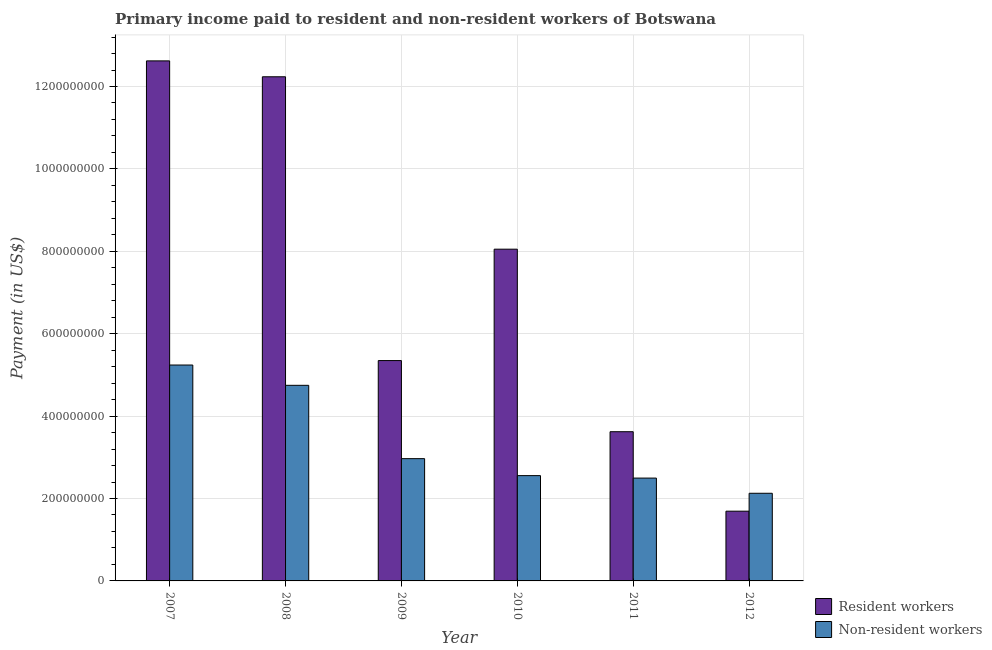How many different coloured bars are there?
Your answer should be very brief. 2. How many bars are there on the 5th tick from the right?
Keep it short and to the point. 2. What is the label of the 5th group of bars from the left?
Your answer should be very brief. 2011. What is the payment made to non-resident workers in 2012?
Your answer should be very brief. 2.13e+08. Across all years, what is the maximum payment made to resident workers?
Provide a succinct answer. 1.26e+09. Across all years, what is the minimum payment made to non-resident workers?
Ensure brevity in your answer.  2.13e+08. In which year was the payment made to non-resident workers minimum?
Make the answer very short. 2012. What is the total payment made to non-resident workers in the graph?
Make the answer very short. 2.01e+09. What is the difference between the payment made to non-resident workers in 2010 and that in 2011?
Your answer should be compact. 5.99e+06. What is the difference between the payment made to non-resident workers in 2012 and the payment made to resident workers in 2011?
Your answer should be compact. -3.69e+07. What is the average payment made to non-resident workers per year?
Make the answer very short. 3.36e+08. In the year 2012, what is the difference between the payment made to resident workers and payment made to non-resident workers?
Provide a short and direct response. 0. What is the ratio of the payment made to non-resident workers in 2008 to that in 2012?
Provide a short and direct response. 2.23. What is the difference between the highest and the second highest payment made to resident workers?
Provide a succinct answer. 3.86e+07. What is the difference between the highest and the lowest payment made to resident workers?
Provide a short and direct response. 1.09e+09. In how many years, is the payment made to non-resident workers greater than the average payment made to non-resident workers taken over all years?
Your response must be concise. 2. Is the sum of the payment made to resident workers in 2009 and 2012 greater than the maximum payment made to non-resident workers across all years?
Offer a very short reply. No. What does the 2nd bar from the left in 2011 represents?
Provide a succinct answer. Non-resident workers. What does the 1st bar from the right in 2012 represents?
Provide a succinct answer. Non-resident workers. How many bars are there?
Give a very brief answer. 12. Are all the bars in the graph horizontal?
Provide a short and direct response. No. How many years are there in the graph?
Your response must be concise. 6. What is the difference between two consecutive major ticks on the Y-axis?
Keep it short and to the point. 2.00e+08. Does the graph contain grids?
Offer a terse response. Yes. How many legend labels are there?
Provide a succinct answer. 2. How are the legend labels stacked?
Your answer should be compact. Vertical. What is the title of the graph?
Give a very brief answer. Primary income paid to resident and non-resident workers of Botswana. What is the label or title of the Y-axis?
Make the answer very short. Payment (in US$). What is the Payment (in US$) of Resident workers in 2007?
Your answer should be compact. 1.26e+09. What is the Payment (in US$) in Non-resident workers in 2007?
Your answer should be very brief. 5.24e+08. What is the Payment (in US$) of Resident workers in 2008?
Your response must be concise. 1.22e+09. What is the Payment (in US$) of Non-resident workers in 2008?
Ensure brevity in your answer.  4.75e+08. What is the Payment (in US$) in Resident workers in 2009?
Offer a terse response. 5.35e+08. What is the Payment (in US$) in Non-resident workers in 2009?
Provide a short and direct response. 2.97e+08. What is the Payment (in US$) in Resident workers in 2010?
Provide a succinct answer. 8.05e+08. What is the Payment (in US$) of Non-resident workers in 2010?
Your answer should be very brief. 2.56e+08. What is the Payment (in US$) in Resident workers in 2011?
Your response must be concise. 3.62e+08. What is the Payment (in US$) in Non-resident workers in 2011?
Offer a terse response. 2.50e+08. What is the Payment (in US$) in Resident workers in 2012?
Your answer should be very brief. 1.69e+08. What is the Payment (in US$) of Non-resident workers in 2012?
Provide a succinct answer. 2.13e+08. Across all years, what is the maximum Payment (in US$) of Resident workers?
Make the answer very short. 1.26e+09. Across all years, what is the maximum Payment (in US$) in Non-resident workers?
Offer a very short reply. 5.24e+08. Across all years, what is the minimum Payment (in US$) of Resident workers?
Keep it short and to the point. 1.69e+08. Across all years, what is the minimum Payment (in US$) in Non-resident workers?
Your answer should be compact. 2.13e+08. What is the total Payment (in US$) of Resident workers in the graph?
Your answer should be compact. 4.36e+09. What is the total Payment (in US$) in Non-resident workers in the graph?
Provide a succinct answer. 2.01e+09. What is the difference between the Payment (in US$) of Resident workers in 2007 and that in 2008?
Your answer should be compact. 3.86e+07. What is the difference between the Payment (in US$) in Non-resident workers in 2007 and that in 2008?
Offer a very short reply. 4.92e+07. What is the difference between the Payment (in US$) of Resident workers in 2007 and that in 2009?
Give a very brief answer. 7.27e+08. What is the difference between the Payment (in US$) of Non-resident workers in 2007 and that in 2009?
Your answer should be very brief. 2.27e+08. What is the difference between the Payment (in US$) in Resident workers in 2007 and that in 2010?
Keep it short and to the point. 4.57e+08. What is the difference between the Payment (in US$) in Non-resident workers in 2007 and that in 2010?
Give a very brief answer. 2.68e+08. What is the difference between the Payment (in US$) in Resident workers in 2007 and that in 2011?
Offer a very short reply. 9.00e+08. What is the difference between the Payment (in US$) of Non-resident workers in 2007 and that in 2011?
Provide a succinct answer. 2.74e+08. What is the difference between the Payment (in US$) of Resident workers in 2007 and that in 2012?
Your answer should be compact. 1.09e+09. What is the difference between the Payment (in US$) of Non-resident workers in 2007 and that in 2012?
Your response must be concise. 3.11e+08. What is the difference between the Payment (in US$) in Resident workers in 2008 and that in 2009?
Make the answer very short. 6.89e+08. What is the difference between the Payment (in US$) in Non-resident workers in 2008 and that in 2009?
Make the answer very short. 1.78e+08. What is the difference between the Payment (in US$) in Resident workers in 2008 and that in 2010?
Offer a terse response. 4.18e+08. What is the difference between the Payment (in US$) of Non-resident workers in 2008 and that in 2010?
Your answer should be very brief. 2.19e+08. What is the difference between the Payment (in US$) in Resident workers in 2008 and that in 2011?
Your answer should be very brief. 8.61e+08. What is the difference between the Payment (in US$) in Non-resident workers in 2008 and that in 2011?
Offer a very short reply. 2.25e+08. What is the difference between the Payment (in US$) of Resident workers in 2008 and that in 2012?
Make the answer very short. 1.05e+09. What is the difference between the Payment (in US$) in Non-resident workers in 2008 and that in 2012?
Provide a short and direct response. 2.62e+08. What is the difference between the Payment (in US$) of Resident workers in 2009 and that in 2010?
Give a very brief answer. -2.70e+08. What is the difference between the Payment (in US$) in Non-resident workers in 2009 and that in 2010?
Keep it short and to the point. 4.12e+07. What is the difference between the Payment (in US$) of Resident workers in 2009 and that in 2011?
Ensure brevity in your answer.  1.73e+08. What is the difference between the Payment (in US$) in Non-resident workers in 2009 and that in 2011?
Provide a succinct answer. 4.72e+07. What is the difference between the Payment (in US$) of Resident workers in 2009 and that in 2012?
Offer a terse response. 3.66e+08. What is the difference between the Payment (in US$) in Non-resident workers in 2009 and that in 2012?
Make the answer very short. 8.40e+07. What is the difference between the Payment (in US$) in Resident workers in 2010 and that in 2011?
Give a very brief answer. 4.43e+08. What is the difference between the Payment (in US$) in Non-resident workers in 2010 and that in 2011?
Keep it short and to the point. 5.99e+06. What is the difference between the Payment (in US$) of Resident workers in 2010 and that in 2012?
Your answer should be very brief. 6.36e+08. What is the difference between the Payment (in US$) in Non-resident workers in 2010 and that in 2012?
Your answer should be compact. 4.29e+07. What is the difference between the Payment (in US$) of Resident workers in 2011 and that in 2012?
Provide a succinct answer. 1.93e+08. What is the difference between the Payment (in US$) of Non-resident workers in 2011 and that in 2012?
Keep it short and to the point. 3.69e+07. What is the difference between the Payment (in US$) of Resident workers in 2007 and the Payment (in US$) of Non-resident workers in 2008?
Your response must be concise. 7.87e+08. What is the difference between the Payment (in US$) of Resident workers in 2007 and the Payment (in US$) of Non-resident workers in 2009?
Ensure brevity in your answer.  9.65e+08. What is the difference between the Payment (in US$) of Resident workers in 2007 and the Payment (in US$) of Non-resident workers in 2010?
Keep it short and to the point. 1.01e+09. What is the difference between the Payment (in US$) of Resident workers in 2007 and the Payment (in US$) of Non-resident workers in 2011?
Make the answer very short. 1.01e+09. What is the difference between the Payment (in US$) of Resident workers in 2007 and the Payment (in US$) of Non-resident workers in 2012?
Provide a short and direct response. 1.05e+09. What is the difference between the Payment (in US$) in Resident workers in 2008 and the Payment (in US$) in Non-resident workers in 2009?
Your answer should be very brief. 9.27e+08. What is the difference between the Payment (in US$) in Resident workers in 2008 and the Payment (in US$) in Non-resident workers in 2010?
Offer a terse response. 9.68e+08. What is the difference between the Payment (in US$) in Resident workers in 2008 and the Payment (in US$) in Non-resident workers in 2011?
Keep it short and to the point. 9.74e+08. What is the difference between the Payment (in US$) in Resident workers in 2008 and the Payment (in US$) in Non-resident workers in 2012?
Provide a short and direct response. 1.01e+09. What is the difference between the Payment (in US$) in Resident workers in 2009 and the Payment (in US$) in Non-resident workers in 2010?
Keep it short and to the point. 2.79e+08. What is the difference between the Payment (in US$) in Resident workers in 2009 and the Payment (in US$) in Non-resident workers in 2011?
Your answer should be compact. 2.85e+08. What is the difference between the Payment (in US$) of Resident workers in 2009 and the Payment (in US$) of Non-resident workers in 2012?
Offer a terse response. 3.22e+08. What is the difference between the Payment (in US$) of Resident workers in 2010 and the Payment (in US$) of Non-resident workers in 2011?
Your response must be concise. 5.56e+08. What is the difference between the Payment (in US$) of Resident workers in 2010 and the Payment (in US$) of Non-resident workers in 2012?
Ensure brevity in your answer.  5.92e+08. What is the difference between the Payment (in US$) in Resident workers in 2011 and the Payment (in US$) in Non-resident workers in 2012?
Make the answer very short. 1.49e+08. What is the average Payment (in US$) in Resident workers per year?
Keep it short and to the point. 7.26e+08. What is the average Payment (in US$) in Non-resident workers per year?
Keep it short and to the point. 3.36e+08. In the year 2007, what is the difference between the Payment (in US$) of Resident workers and Payment (in US$) of Non-resident workers?
Keep it short and to the point. 7.38e+08. In the year 2008, what is the difference between the Payment (in US$) of Resident workers and Payment (in US$) of Non-resident workers?
Your answer should be very brief. 7.49e+08. In the year 2009, what is the difference between the Payment (in US$) of Resident workers and Payment (in US$) of Non-resident workers?
Your answer should be compact. 2.38e+08. In the year 2010, what is the difference between the Payment (in US$) in Resident workers and Payment (in US$) in Non-resident workers?
Provide a short and direct response. 5.50e+08. In the year 2011, what is the difference between the Payment (in US$) of Resident workers and Payment (in US$) of Non-resident workers?
Your answer should be compact. 1.13e+08. In the year 2012, what is the difference between the Payment (in US$) in Resident workers and Payment (in US$) in Non-resident workers?
Make the answer very short. -4.35e+07. What is the ratio of the Payment (in US$) of Resident workers in 2007 to that in 2008?
Make the answer very short. 1.03. What is the ratio of the Payment (in US$) of Non-resident workers in 2007 to that in 2008?
Make the answer very short. 1.1. What is the ratio of the Payment (in US$) of Resident workers in 2007 to that in 2009?
Offer a very short reply. 2.36. What is the ratio of the Payment (in US$) in Non-resident workers in 2007 to that in 2009?
Provide a short and direct response. 1.77. What is the ratio of the Payment (in US$) in Resident workers in 2007 to that in 2010?
Keep it short and to the point. 1.57. What is the ratio of the Payment (in US$) in Non-resident workers in 2007 to that in 2010?
Your answer should be compact. 2.05. What is the ratio of the Payment (in US$) in Resident workers in 2007 to that in 2011?
Your response must be concise. 3.49. What is the ratio of the Payment (in US$) in Non-resident workers in 2007 to that in 2011?
Keep it short and to the point. 2.1. What is the ratio of the Payment (in US$) in Resident workers in 2007 to that in 2012?
Keep it short and to the point. 7.46. What is the ratio of the Payment (in US$) in Non-resident workers in 2007 to that in 2012?
Give a very brief answer. 2.46. What is the ratio of the Payment (in US$) in Resident workers in 2008 to that in 2009?
Your response must be concise. 2.29. What is the ratio of the Payment (in US$) of Non-resident workers in 2008 to that in 2009?
Your response must be concise. 1.6. What is the ratio of the Payment (in US$) of Resident workers in 2008 to that in 2010?
Make the answer very short. 1.52. What is the ratio of the Payment (in US$) in Non-resident workers in 2008 to that in 2010?
Provide a short and direct response. 1.86. What is the ratio of the Payment (in US$) in Resident workers in 2008 to that in 2011?
Your response must be concise. 3.38. What is the ratio of the Payment (in US$) in Non-resident workers in 2008 to that in 2011?
Give a very brief answer. 1.9. What is the ratio of the Payment (in US$) in Resident workers in 2008 to that in 2012?
Your answer should be compact. 7.23. What is the ratio of the Payment (in US$) of Non-resident workers in 2008 to that in 2012?
Your answer should be compact. 2.23. What is the ratio of the Payment (in US$) of Resident workers in 2009 to that in 2010?
Your answer should be compact. 0.66. What is the ratio of the Payment (in US$) in Non-resident workers in 2009 to that in 2010?
Make the answer very short. 1.16. What is the ratio of the Payment (in US$) in Resident workers in 2009 to that in 2011?
Provide a short and direct response. 1.48. What is the ratio of the Payment (in US$) of Non-resident workers in 2009 to that in 2011?
Provide a succinct answer. 1.19. What is the ratio of the Payment (in US$) in Resident workers in 2009 to that in 2012?
Keep it short and to the point. 3.16. What is the ratio of the Payment (in US$) in Non-resident workers in 2009 to that in 2012?
Keep it short and to the point. 1.4. What is the ratio of the Payment (in US$) of Resident workers in 2010 to that in 2011?
Your answer should be very brief. 2.22. What is the ratio of the Payment (in US$) in Non-resident workers in 2010 to that in 2011?
Provide a short and direct response. 1.02. What is the ratio of the Payment (in US$) in Resident workers in 2010 to that in 2012?
Ensure brevity in your answer.  4.76. What is the ratio of the Payment (in US$) in Non-resident workers in 2010 to that in 2012?
Keep it short and to the point. 1.2. What is the ratio of the Payment (in US$) in Resident workers in 2011 to that in 2012?
Keep it short and to the point. 2.14. What is the ratio of the Payment (in US$) of Non-resident workers in 2011 to that in 2012?
Make the answer very short. 1.17. What is the difference between the highest and the second highest Payment (in US$) in Resident workers?
Offer a very short reply. 3.86e+07. What is the difference between the highest and the second highest Payment (in US$) of Non-resident workers?
Give a very brief answer. 4.92e+07. What is the difference between the highest and the lowest Payment (in US$) of Resident workers?
Your answer should be very brief. 1.09e+09. What is the difference between the highest and the lowest Payment (in US$) in Non-resident workers?
Provide a succinct answer. 3.11e+08. 